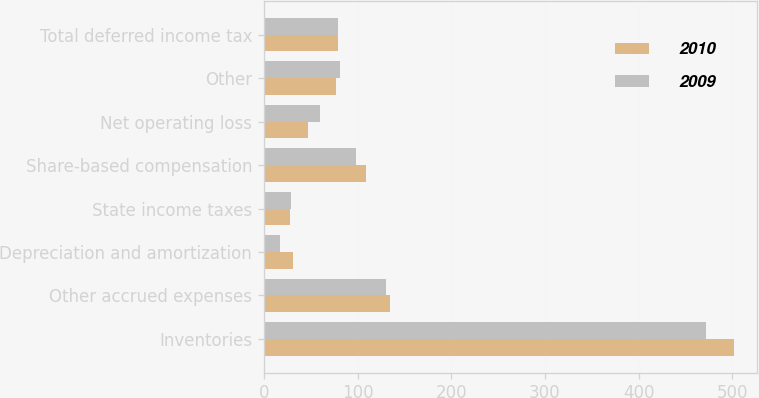Convert chart. <chart><loc_0><loc_0><loc_500><loc_500><stacked_bar_chart><ecel><fcel>Inventories<fcel>Other accrued expenses<fcel>Depreciation and amortization<fcel>State income taxes<fcel>Share-based compensation<fcel>Net operating loss<fcel>Other<fcel>Total deferred income tax<nl><fcel>2010<fcel>501.5<fcel>134.5<fcel>30.7<fcel>27.7<fcel>109<fcel>47.2<fcel>77<fcel>79.4<nl><fcel>2009<fcel>471.7<fcel>130.7<fcel>17.3<fcel>29<fcel>98.5<fcel>59.7<fcel>81.8<fcel>79.4<nl></chart> 